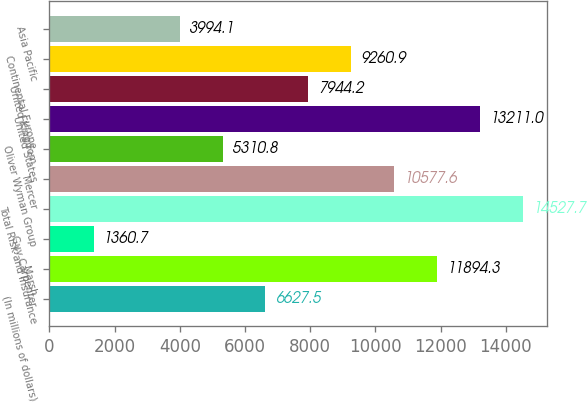Convert chart to OTSL. <chart><loc_0><loc_0><loc_500><loc_500><bar_chart><fcel>(In millions of dollars)<fcel>Marsh<fcel>Guy Carpenter<fcel>Total Risk and Insurance<fcel>Mercer<fcel>Oliver Wyman Group<fcel>United States<fcel>United Kingdom<fcel>Continental Europe<fcel>Asia Pacific<nl><fcel>6627.5<fcel>11894.3<fcel>1360.7<fcel>14527.7<fcel>10577.6<fcel>5310.8<fcel>13211<fcel>7944.2<fcel>9260.9<fcel>3994.1<nl></chart> 